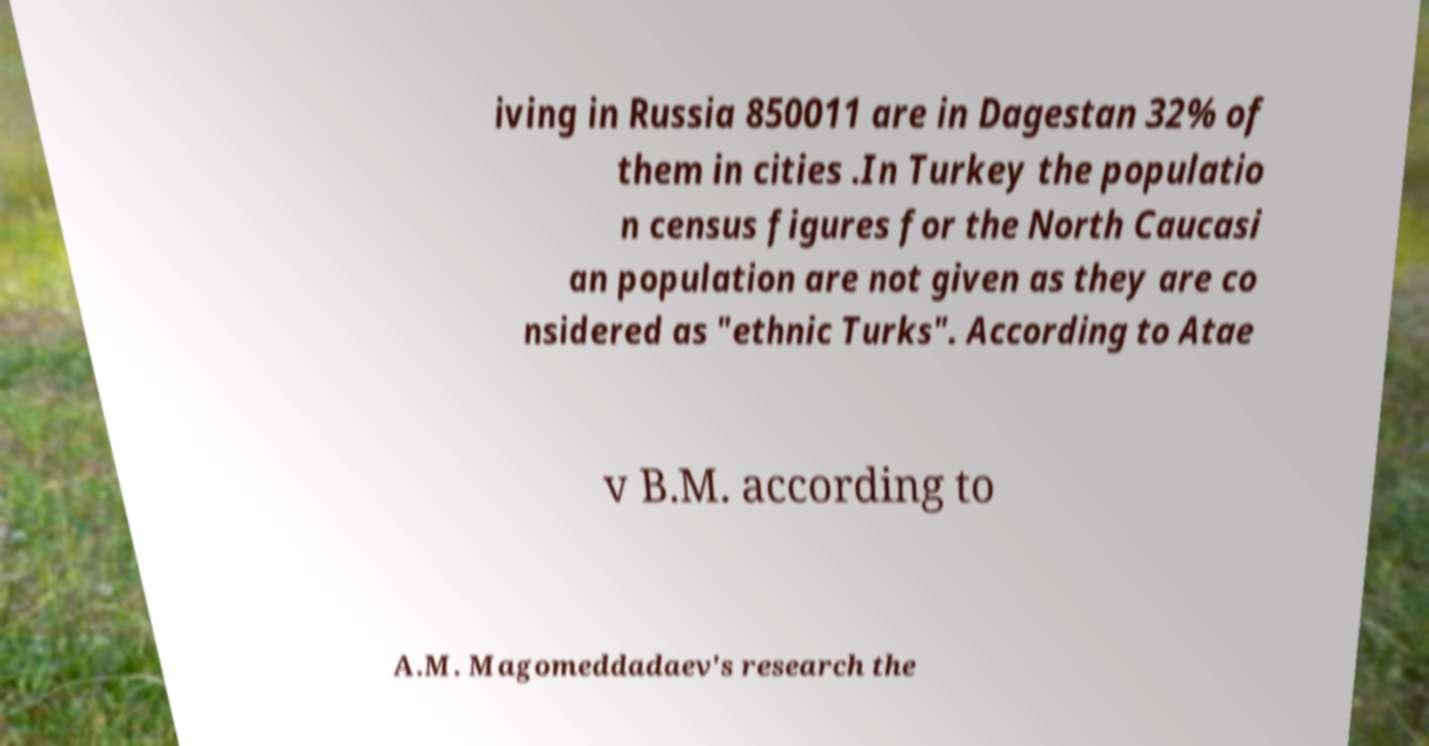There's text embedded in this image that I need extracted. Can you transcribe it verbatim? iving in Russia 850011 are in Dagestan 32% of them in cities .In Turkey the populatio n census figures for the North Caucasi an population are not given as they are co nsidered as "ethnic Turks". According to Atae v B.M. according to A.M. Magomeddadaev's research the 